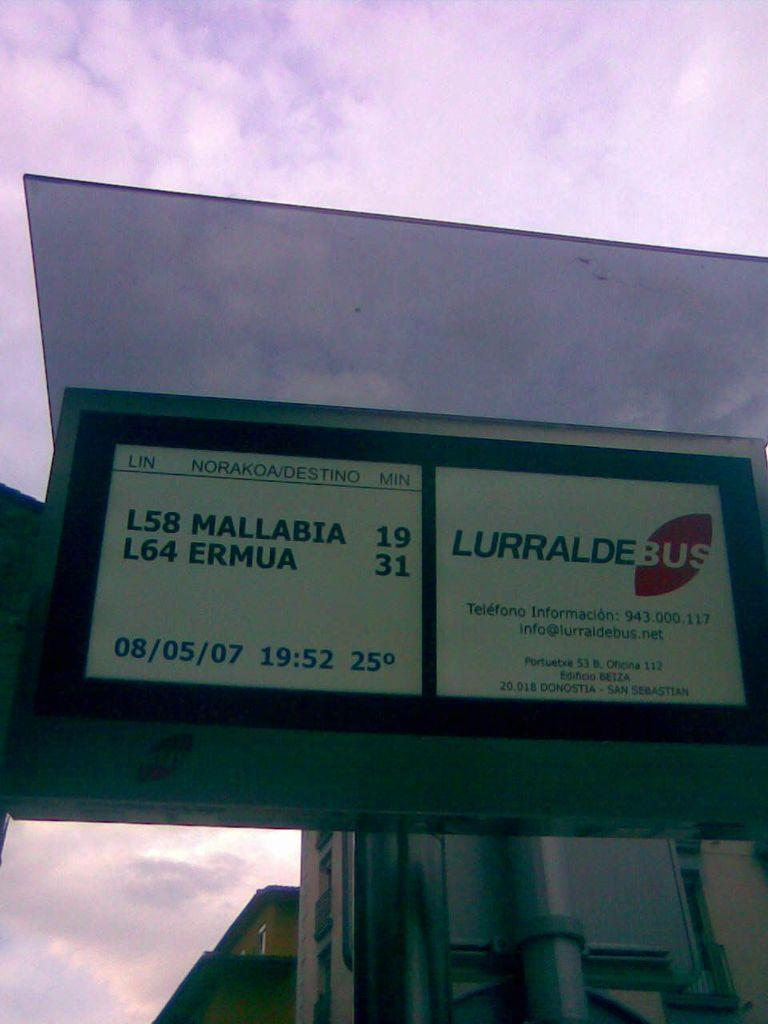<image>
Render a clear and concise summary of the photo. A bus station sign for Lurralde Bus and the date of 08/05/07. 